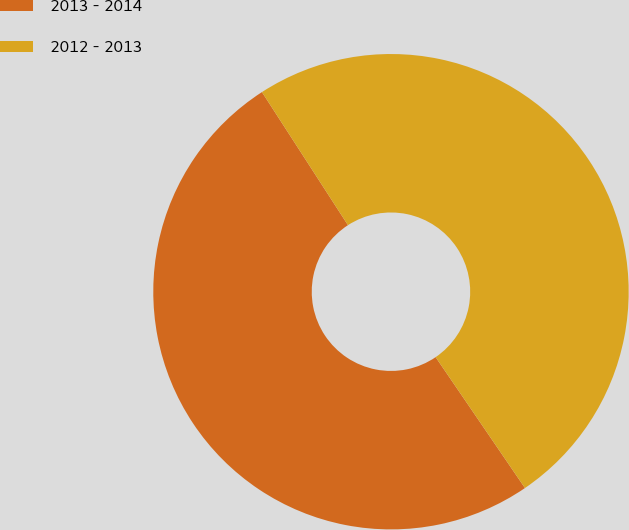Convert chart to OTSL. <chart><loc_0><loc_0><loc_500><loc_500><pie_chart><fcel>2013 - 2014<fcel>2012 - 2013<nl><fcel>50.4%<fcel>49.6%<nl></chart> 